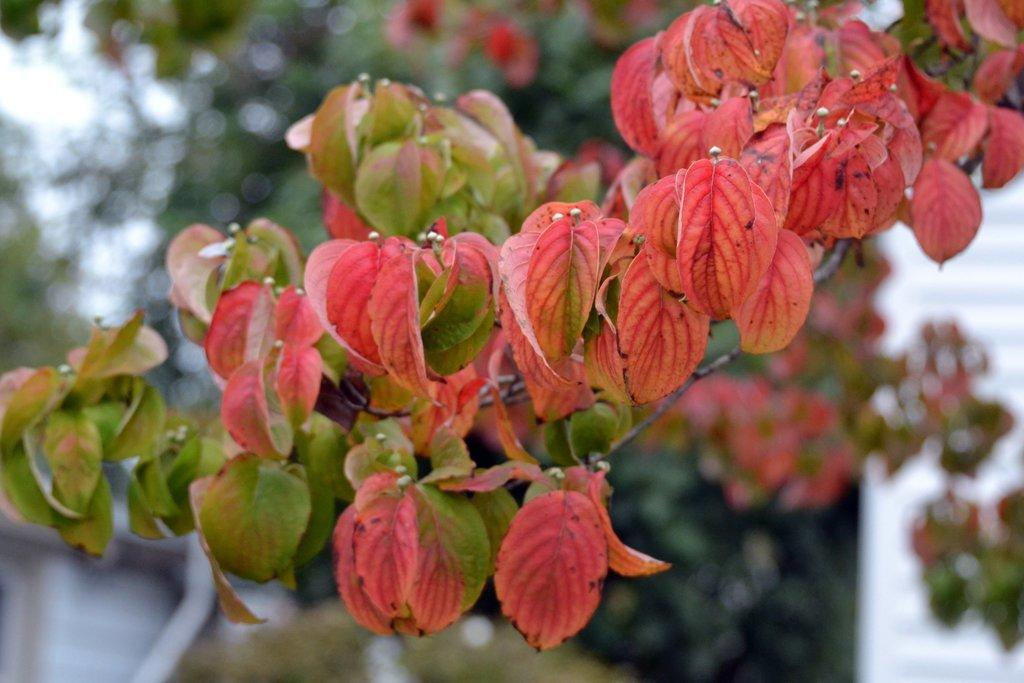What is present in the image? There is a plant in the image. Can you describe the appearance of the plant? The plant has red and green leaves. What can be seen in the background of the image? There are many trees visible in the background of the image. Is there a wall or lock visible in the image? No, there is no wall or lock present in the image; it features a plant with red and green leaves and trees in the background. 